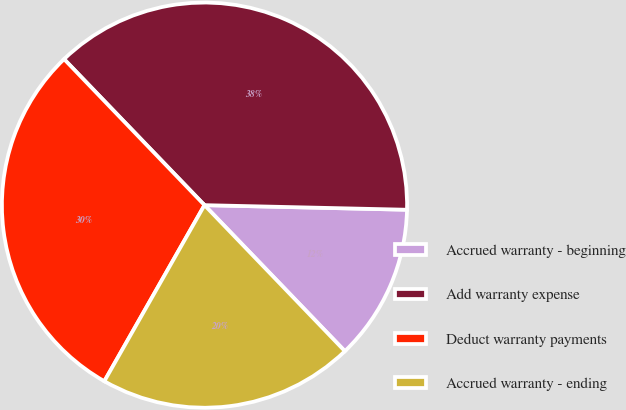<chart> <loc_0><loc_0><loc_500><loc_500><pie_chart><fcel>Accrued warranty - beginning<fcel>Add warranty expense<fcel>Deduct warranty payments<fcel>Accrued warranty - ending<nl><fcel>12.45%<fcel>37.55%<fcel>29.58%<fcel>20.42%<nl></chart> 